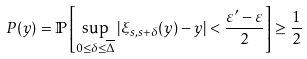Convert formula to latex. <formula><loc_0><loc_0><loc_500><loc_500>P ( y ) = \mathbb { P } \left [ \sup _ { 0 \leq \delta \leq \overline { \Delta } } | \xi _ { s , s + \delta } ( y ) - y | < \frac { \varepsilon ^ { \prime } - \varepsilon } { 2 } \right ] \geq \frac { 1 } { 2 }</formula> 